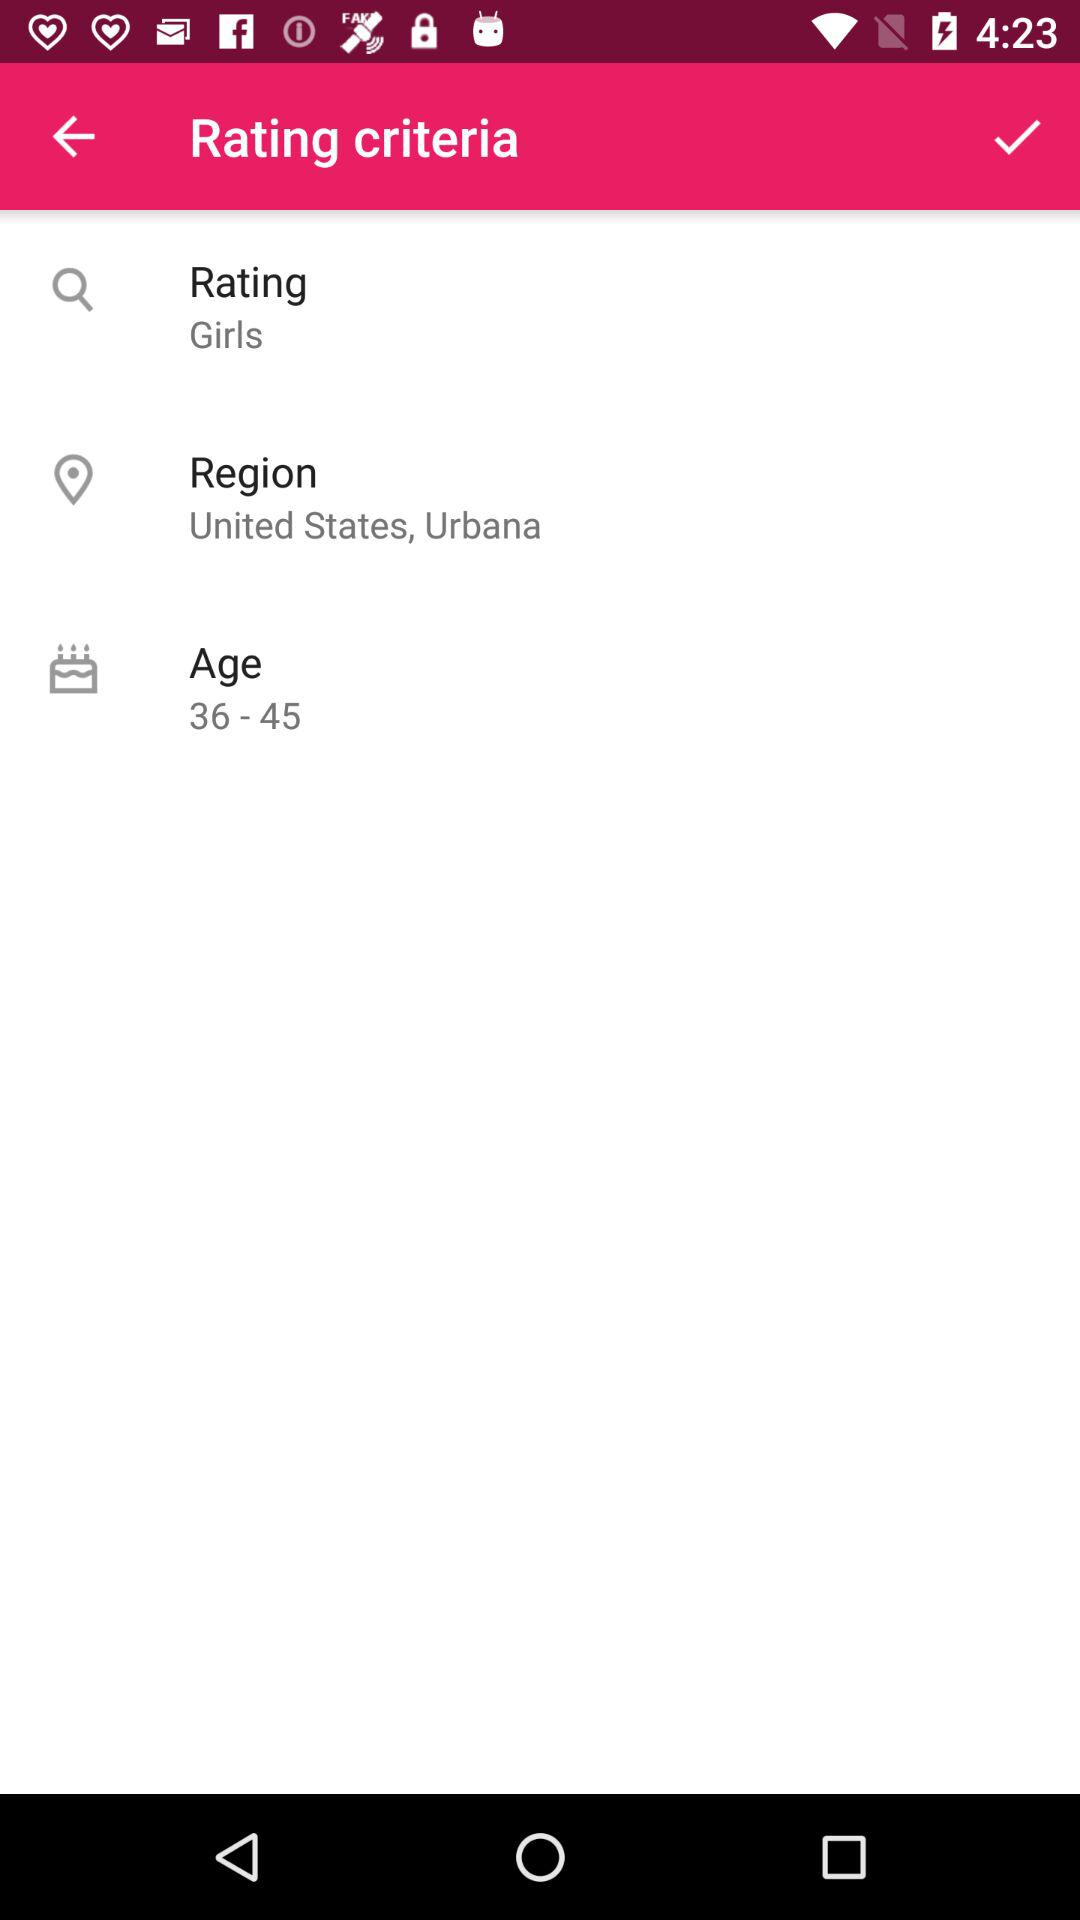What improvements could be made to the interface shown? To improve the interface, more visual hierarchy can be implemented to emphasize key elements. Additionally, providing a clearer indication of what the rating system entails or its purpose as well as incorporating a more diverse range of filters could offer a more inclusive and user-friendly experience. The font sizes and the overall color scheme could also be adjusted for better accessibility. 